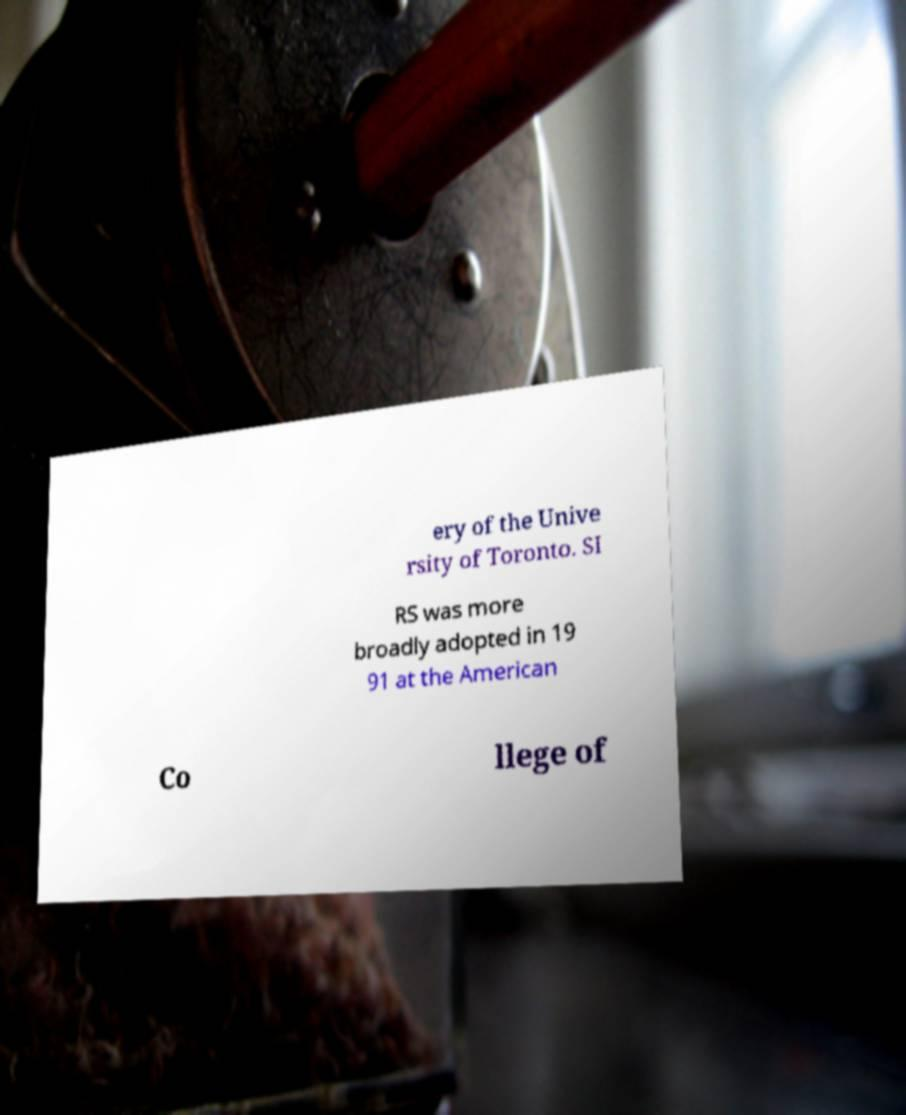Could you extract and type out the text from this image? ery of the Unive rsity of Toronto. SI RS was more broadly adopted in 19 91 at the American Co llege of 